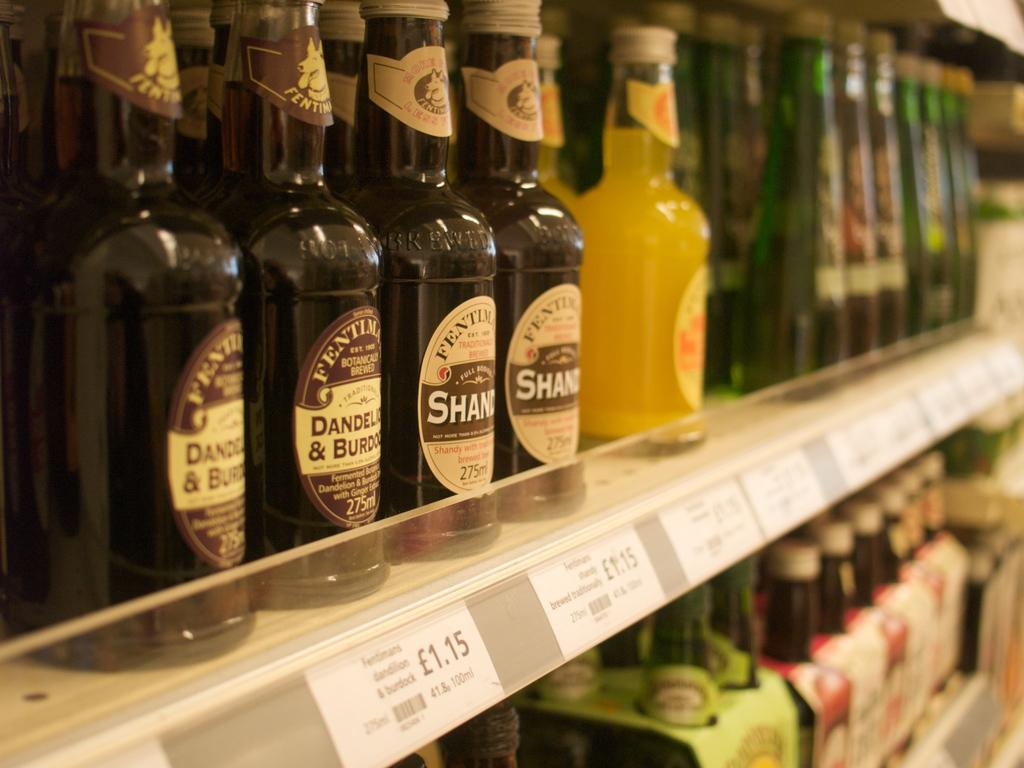<image>
Give a short and clear explanation of the subsequent image. Bottles lines shelves with the far left group showing a price of 1.15. 